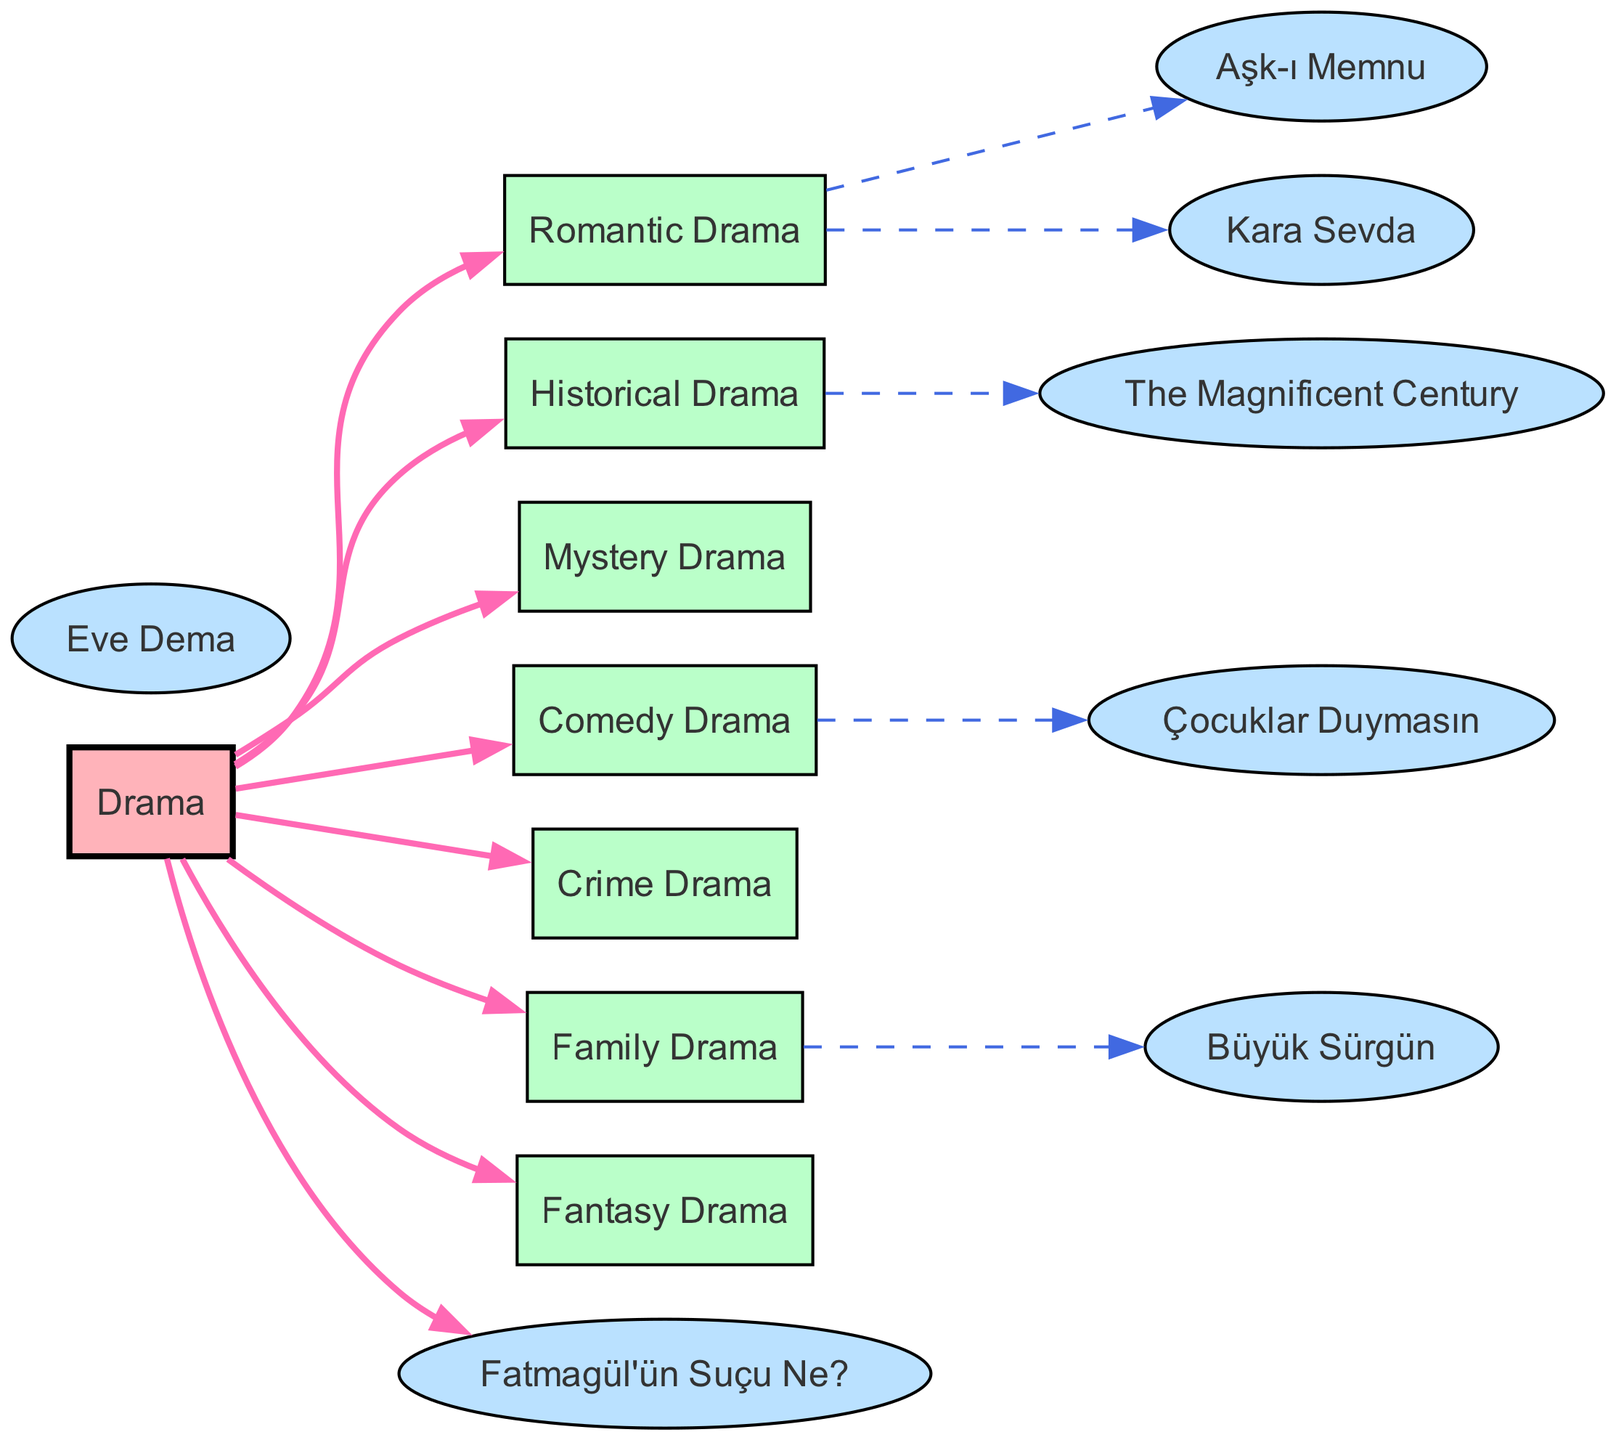What's the total number of nodes in the diagram? The diagram lists a total of 15 nodes, each representing a genre or series in the evolution of Turkish television drama. By counting them directly from the nodes section in the provided data, we find: Drama, Romantic Drama, Historical Drama, Mystery Drama, Comedy Drama, Crime Drama, Family Drama, Fantasy Drama, The Magnificent Century, Eve Dema, Aşk-ı Memnu, Kara Sevda, Çocuklar Duymasın, Fatmagül'ün Suçu Ne?, and Büyük Sürgün.
Answer: 15 Which series is categorized under Romantic Drama? The diagram shows two edges stemming from the Romantic Drama node, connecting it to Aşk-ı Memnu and Kara Sevda. By examining these edges, we can see that both series are designated as Romantic Drama.
Answer: Aşk-ı Memnu, Kara Sevda What is the relationship between Comedy Drama and Çocuklar Duymasın? In the diagram, there is a direct edge from the Comedy Drama node to the series node Çocuklar Duymasın. This indicates that Çocuklar Duymasın is a series that falls under the category of Comedy Drama.
Answer: Çocuklar Duymasın is Comedy Drama How many different genres are directly connected to the main Drama node? The Drama node has edges that connect to seven different genres: Romantic Drama, Historical Drama, Mystery Drama, Comedy Drama, Crime Drama, Family Drama, and Fantasy Drama. Counting these edges gives us the total number of genres connected to Drama.
Answer: 7 Which genre does The Magnificent Century belong to? The directed graph indicates that The Magnificent Century is directly connected to the Historical Drama node. Thus, it belongs to the genre of Historical Drama. This connection can be directly seen as an edge from Historical Drama to The Magnificent Century.
Answer: Historical Drama Which genre has only one associated series in this diagram? Examining the edges, Family Drama has only one connected series, which is Büyük Sürgün. This is identified by the single edge leading from Family Drama to the series node.
Answer: Family Drama What genre is connected to the series Fatmagül'ün Suçu Ne? The diagram shows that there is an edge from the Drama node to Fatmagül'ün Suçu Ne as well. Therefore, Fatmagül'ün Suçu Ne falls under the general category of Drama. This connection indicates that it’s a drama series, but does not belong to any specific sub-genre as illustrated in the diagram.
Answer: Drama What type of drama is depicted by Eve Dema? According to the diagram, Eve Dema does not have a specific genre linkage in this dataset, indicating it represents a standalone entity. It is not directly connected to a genre from the Drama node based on the data provided. However, by its name, it can be presumed to relate to Family Drama but is unassociated within this context.
Answer: None (or presumed Family Drama) 